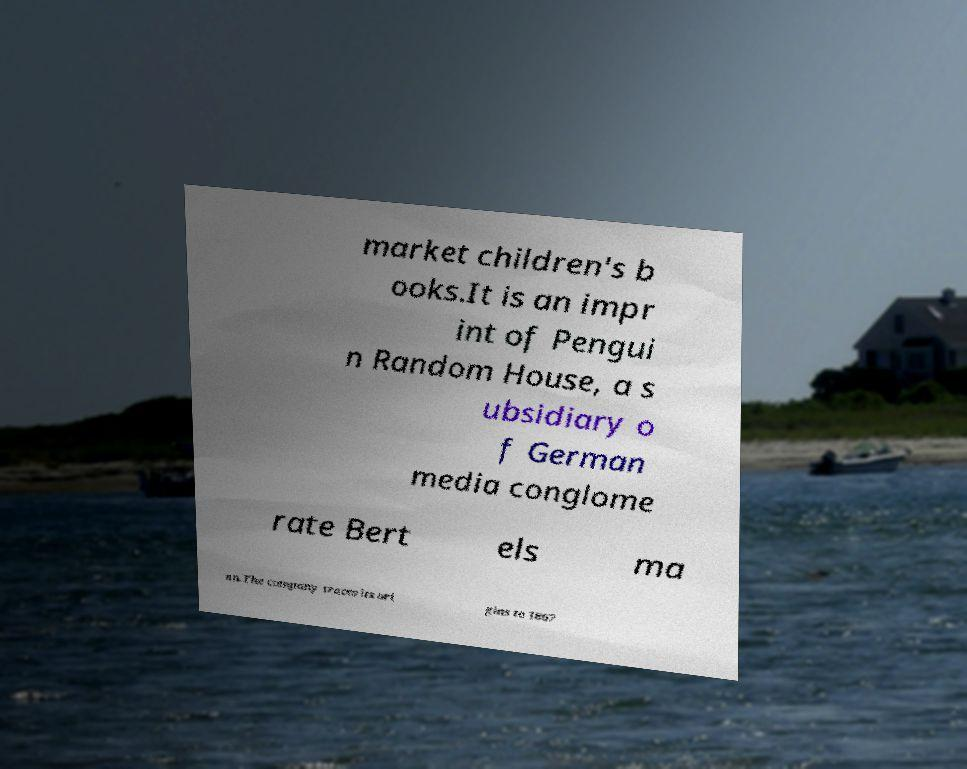For documentation purposes, I need the text within this image transcribed. Could you provide that? market children's b ooks.It is an impr int of Pengui n Random House, a s ubsidiary o f German media conglome rate Bert els ma nn.The company traces its ori gins to 1867 